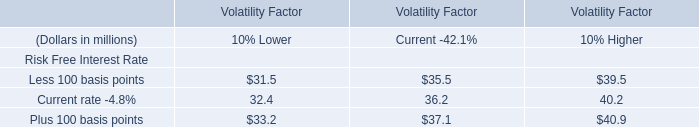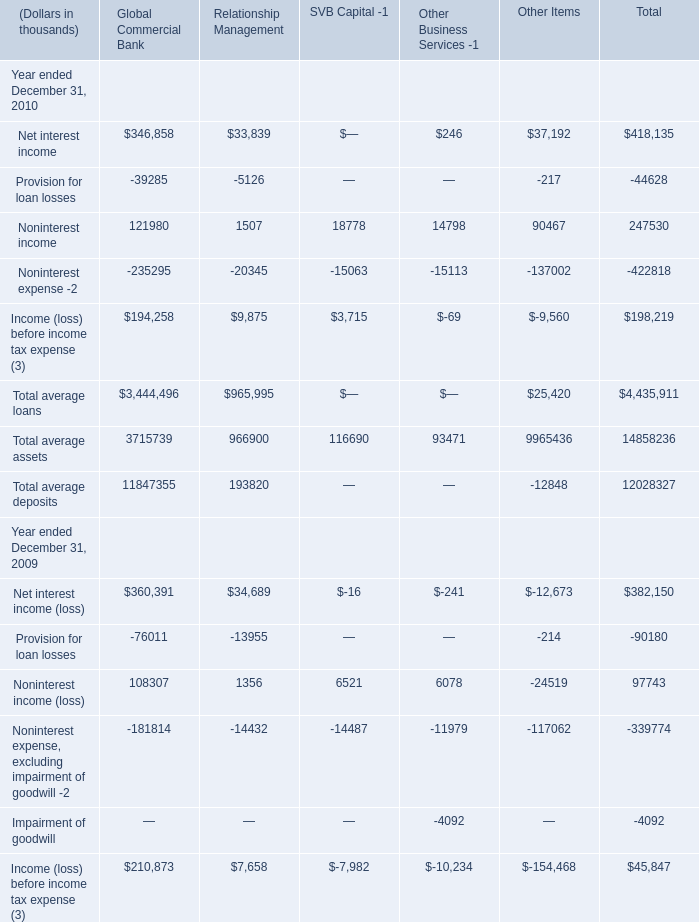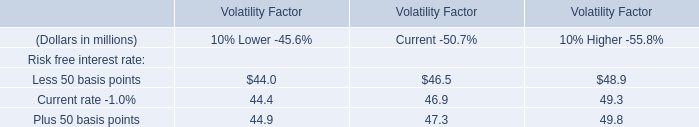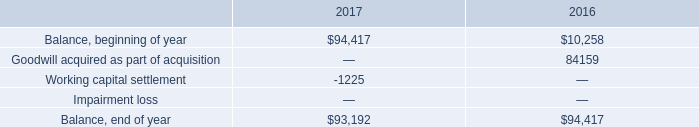what percent did the company's goodwill balance increase between the between the beginning of 2016 and the end of 2017? 
Computations: ((93192 - 10258) / 10258)
Answer: 8.08481. 